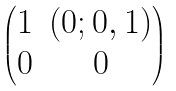Convert formula to latex. <formula><loc_0><loc_0><loc_500><loc_500>\begin{pmatrix} 1 & ( 0 ; 0 , 1 ) \\ 0 & 0 \end{pmatrix}</formula> 